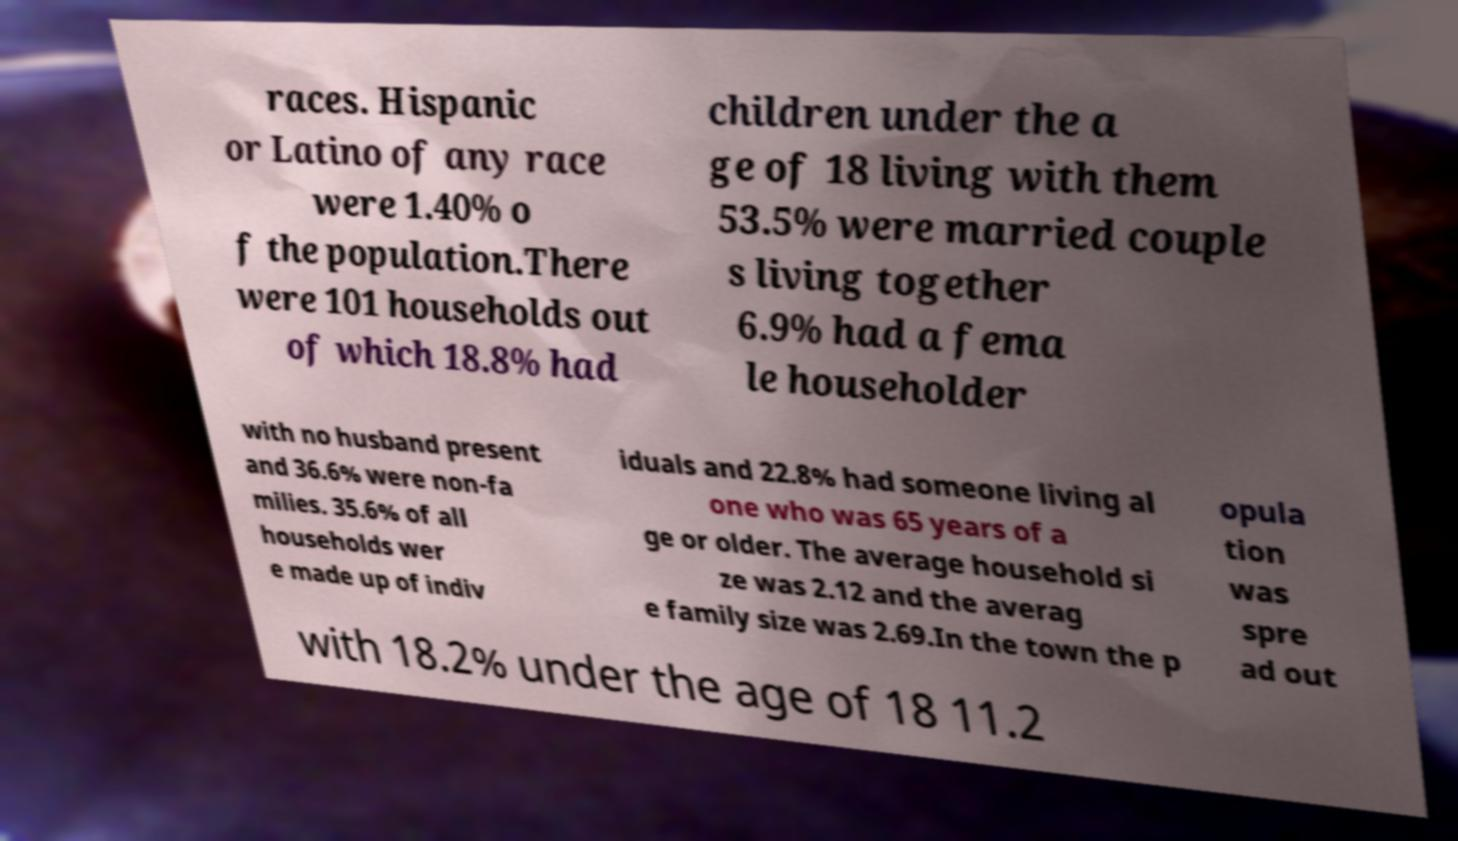What messages or text are displayed in this image? I need them in a readable, typed format. races. Hispanic or Latino of any race were 1.40% o f the population.There were 101 households out of which 18.8% had children under the a ge of 18 living with them 53.5% were married couple s living together 6.9% had a fema le householder with no husband present and 36.6% were non-fa milies. 35.6% of all households wer e made up of indiv iduals and 22.8% had someone living al one who was 65 years of a ge or older. The average household si ze was 2.12 and the averag e family size was 2.69.In the town the p opula tion was spre ad out with 18.2% under the age of 18 11.2 